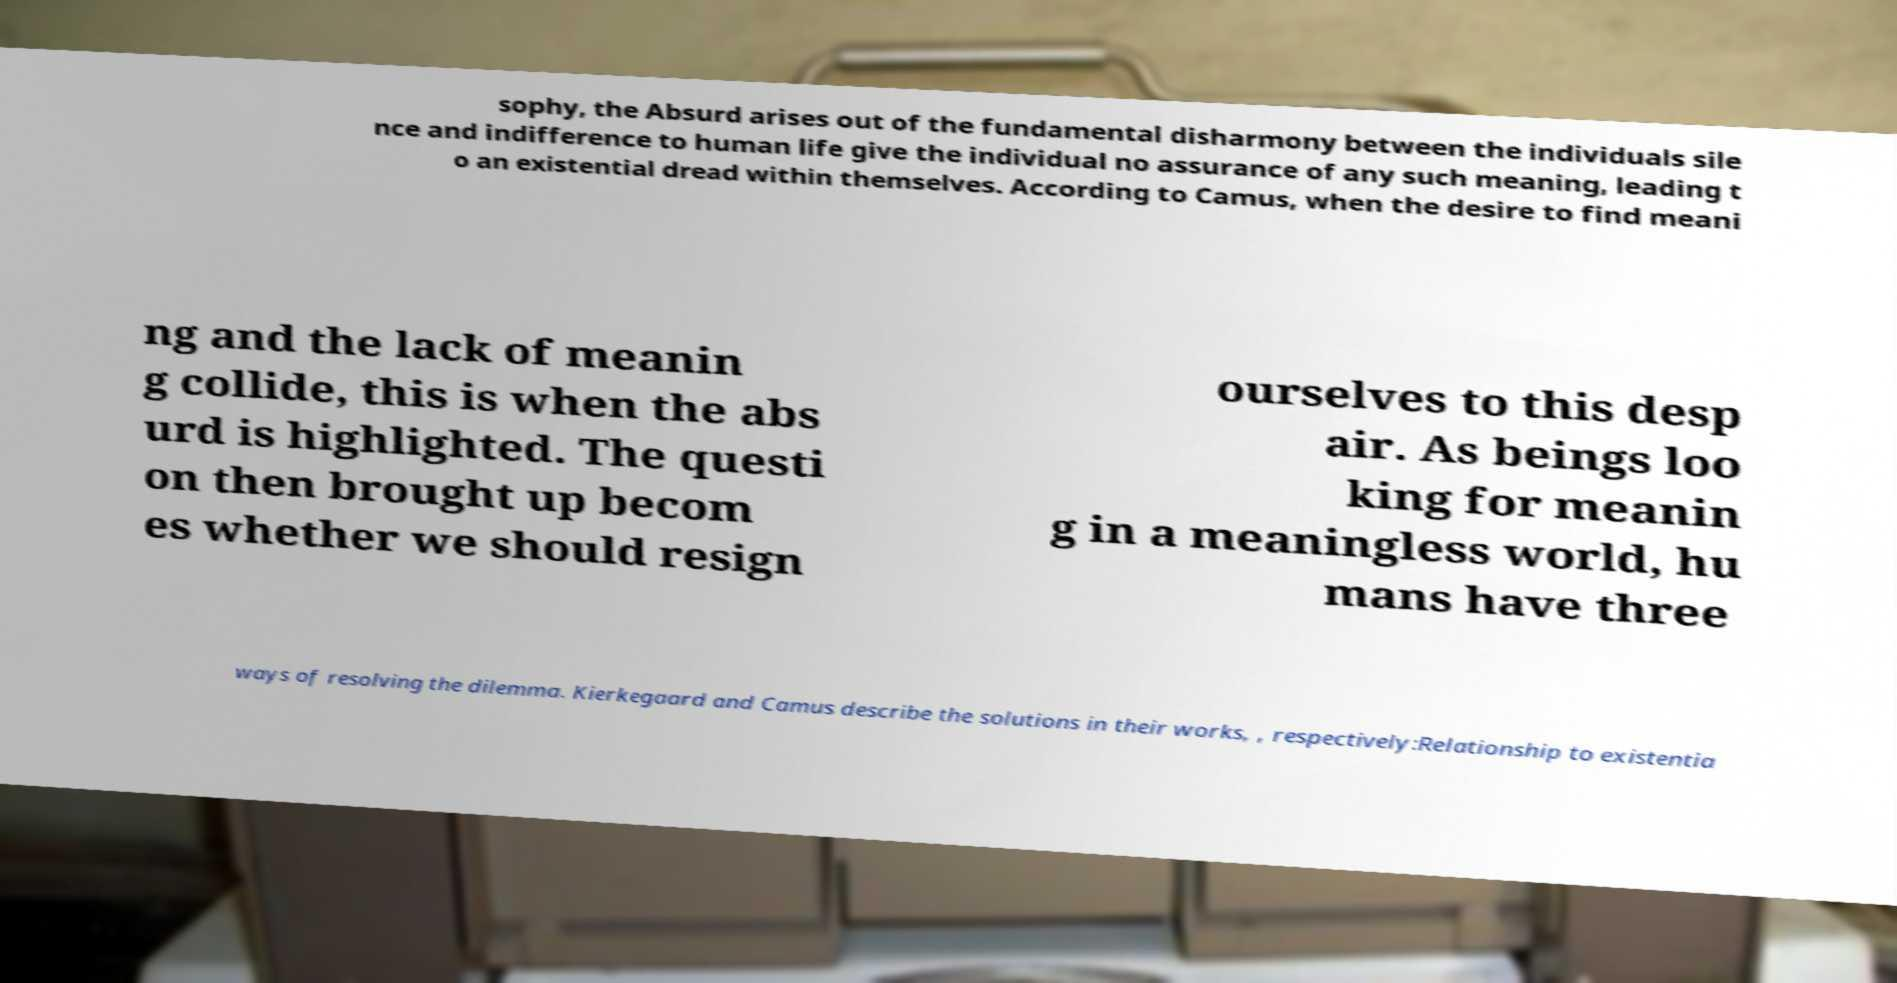Could you extract and type out the text from this image? sophy, the Absurd arises out of the fundamental disharmony between the individuals sile nce and indifference to human life give the individual no assurance of any such meaning, leading t o an existential dread within themselves. According to Camus, when the desire to find meani ng and the lack of meanin g collide, this is when the abs urd is highlighted. The questi on then brought up becom es whether we should resign ourselves to this desp air. As beings loo king for meanin g in a meaningless world, hu mans have three ways of resolving the dilemma. Kierkegaard and Camus describe the solutions in their works, , respectively:Relationship to existentia 